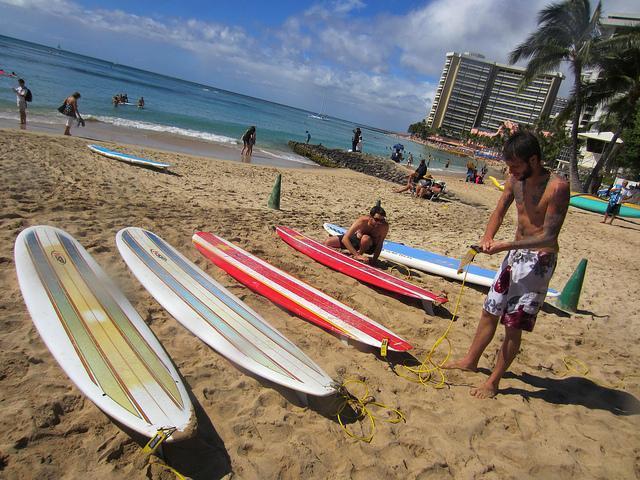How many surfboards are shown?
Give a very brief answer. 6. How many surfboards can be seen?
Give a very brief answer. 5. How many people are in the photo?
Give a very brief answer. 2. How many bottles of wine do you see?
Give a very brief answer. 0. 